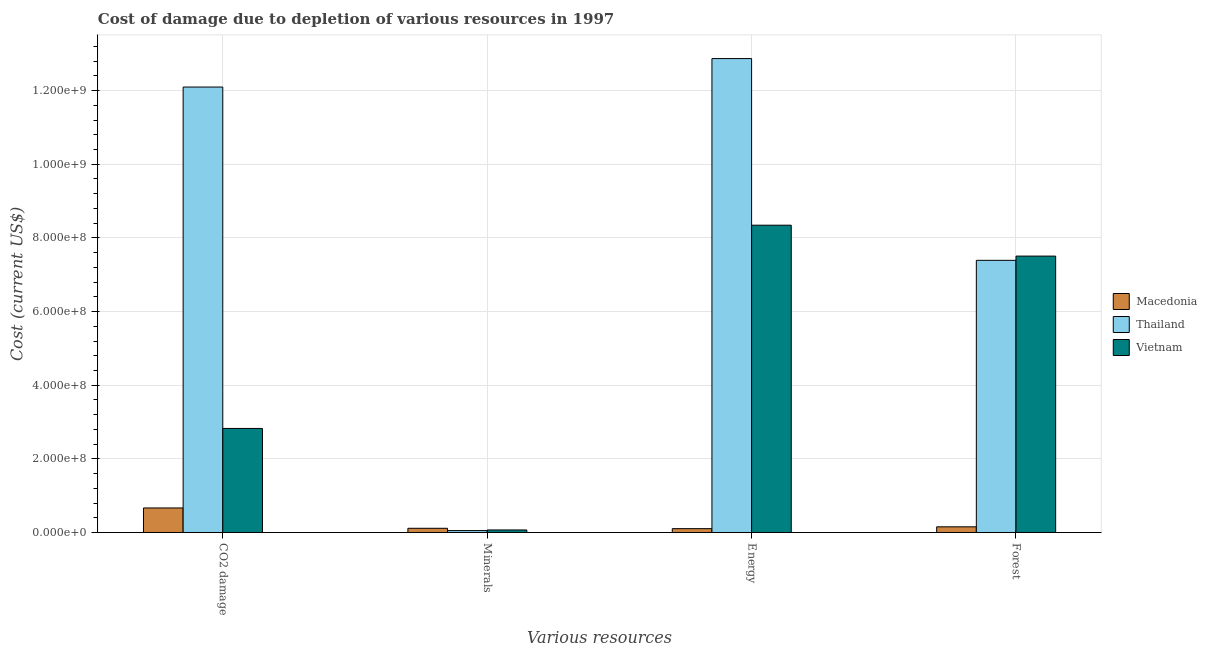How many different coloured bars are there?
Give a very brief answer. 3. How many groups of bars are there?
Offer a terse response. 4. Are the number of bars per tick equal to the number of legend labels?
Make the answer very short. Yes. Are the number of bars on each tick of the X-axis equal?
Make the answer very short. Yes. How many bars are there on the 2nd tick from the left?
Offer a very short reply. 3. How many bars are there on the 2nd tick from the right?
Ensure brevity in your answer.  3. What is the label of the 2nd group of bars from the left?
Make the answer very short. Minerals. What is the cost of damage due to depletion of energy in Macedonia?
Your answer should be very brief. 1.04e+07. Across all countries, what is the maximum cost of damage due to depletion of minerals?
Your answer should be compact. 1.14e+07. Across all countries, what is the minimum cost of damage due to depletion of forests?
Keep it short and to the point. 1.54e+07. In which country was the cost of damage due to depletion of forests maximum?
Provide a short and direct response. Vietnam. In which country was the cost of damage due to depletion of minerals minimum?
Ensure brevity in your answer.  Thailand. What is the total cost of damage due to depletion of minerals in the graph?
Keep it short and to the point. 2.34e+07. What is the difference between the cost of damage due to depletion of coal in Vietnam and that in Macedonia?
Provide a short and direct response. 2.16e+08. What is the difference between the cost of damage due to depletion of coal in Thailand and the cost of damage due to depletion of energy in Vietnam?
Give a very brief answer. 3.75e+08. What is the average cost of damage due to depletion of minerals per country?
Offer a terse response. 7.80e+06. What is the difference between the cost of damage due to depletion of minerals and cost of damage due to depletion of coal in Vietnam?
Give a very brief answer. -2.76e+08. In how many countries, is the cost of damage due to depletion of forests greater than 520000000 US$?
Your answer should be very brief. 2. What is the ratio of the cost of damage due to depletion of coal in Macedonia to that in Thailand?
Your answer should be compact. 0.06. Is the cost of damage due to depletion of energy in Vietnam less than that in Thailand?
Provide a succinct answer. Yes. What is the difference between the highest and the second highest cost of damage due to depletion of coal?
Provide a succinct answer. 9.27e+08. What is the difference between the highest and the lowest cost of damage due to depletion of minerals?
Offer a very short reply. 6.23e+06. Is the sum of the cost of damage due to depletion of energy in Thailand and Macedonia greater than the maximum cost of damage due to depletion of coal across all countries?
Offer a terse response. Yes. Is it the case that in every country, the sum of the cost of damage due to depletion of forests and cost of damage due to depletion of energy is greater than the sum of cost of damage due to depletion of coal and cost of damage due to depletion of minerals?
Keep it short and to the point. Yes. What does the 1st bar from the left in Minerals represents?
Provide a short and direct response. Macedonia. What does the 2nd bar from the right in Energy represents?
Your response must be concise. Thailand. Are the values on the major ticks of Y-axis written in scientific E-notation?
Offer a terse response. Yes. Where does the legend appear in the graph?
Give a very brief answer. Center right. What is the title of the graph?
Your response must be concise. Cost of damage due to depletion of various resources in 1997 . Does "Guam" appear as one of the legend labels in the graph?
Ensure brevity in your answer.  No. What is the label or title of the X-axis?
Offer a terse response. Various resources. What is the label or title of the Y-axis?
Make the answer very short. Cost (current US$). What is the Cost (current US$) in Macedonia in CO2 damage?
Your response must be concise. 6.66e+07. What is the Cost (current US$) in Thailand in CO2 damage?
Your answer should be very brief. 1.21e+09. What is the Cost (current US$) in Vietnam in CO2 damage?
Your response must be concise. 2.83e+08. What is the Cost (current US$) in Macedonia in Minerals?
Provide a succinct answer. 1.14e+07. What is the Cost (current US$) of Thailand in Minerals?
Offer a very short reply. 5.15e+06. What is the Cost (current US$) in Vietnam in Minerals?
Your answer should be compact. 6.86e+06. What is the Cost (current US$) of Macedonia in Energy?
Make the answer very short. 1.04e+07. What is the Cost (current US$) of Thailand in Energy?
Provide a succinct answer. 1.29e+09. What is the Cost (current US$) in Vietnam in Energy?
Provide a short and direct response. 8.35e+08. What is the Cost (current US$) in Macedonia in Forest?
Offer a terse response. 1.54e+07. What is the Cost (current US$) of Thailand in Forest?
Your answer should be compact. 7.39e+08. What is the Cost (current US$) of Vietnam in Forest?
Offer a very short reply. 7.51e+08. Across all Various resources, what is the maximum Cost (current US$) of Macedonia?
Ensure brevity in your answer.  6.66e+07. Across all Various resources, what is the maximum Cost (current US$) in Thailand?
Your response must be concise. 1.29e+09. Across all Various resources, what is the maximum Cost (current US$) in Vietnam?
Make the answer very short. 8.35e+08. Across all Various resources, what is the minimum Cost (current US$) in Macedonia?
Keep it short and to the point. 1.04e+07. Across all Various resources, what is the minimum Cost (current US$) in Thailand?
Keep it short and to the point. 5.15e+06. Across all Various resources, what is the minimum Cost (current US$) of Vietnam?
Ensure brevity in your answer.  6.86e+06. What is the total Cost (current US$) in Macedonia in the graph?
Your response must be concise. 1.04e+08. What is the total Cost (current US$) in Thailand in the graph?
Offer a very short reply. 3.24e+09. What is the total Cost (current US$) in Vietnam in the graph?
Your response must be concise. 1.87e+09. What is the difference between the Cost (current US$) of Macedonia in CO2 damage and that in Minerals?
Make the answer very short. 5.52e+07. What is the difference between the Cost (current US$) in Thailand in CO2 damage and that in Minerals?
Offer a very short reply. 1.20e+09. What is the difference between the Cost (current US$) of Vietnam in CO2 damage and that in Minerals?
Provide a short and direct response. 2.76e+08. What is the difference between the Cost (current US$) of Macedonia in CO2 damage and that in Energy?
Give a very brief answer. 5.62e+07. What is the difference between the Cost (current US$) in Thailand in CO2 damage and that in Energy?
Ensure brevity in your answer.  -7.73e+07. What is the difference between the Cost (current US$) in Vietnam in CO2 damage and that in Energy?
Keep it short and to the point. -5.52e+08. What is the difference between the Cost (current US$) in Macedonia in CO2 damage and that in Forest?
Keep it short and to the point. 5.12e+07. What is the difference between the Cost (current US$) of Thailand in CO2 damage and that in Forest?
Your response must be concise. 4.71e+08. What is the difference between the Cost (current US$) of Vietnam in CO2 damage and that in Forest?
Offer a terse response. -4.68e+08. What is the difference between the Cost (current US$) of Macedonia in Minerals and that in Energy?
Ensure brevity in your answer.  9.60e+05. What is the difference between the Cost (current US$) of Thailand in Minerals and that in Energy?
Ensure brevity in your answer.  -1.28e+09. What is the difference between the Cost (current US$) in Vietnam in Minerals and that in Energy?
Ensure brevity in your answer.  -8.28e+08. What is the difference between the Cost (current US$) in Macedonia in Minerals and that in Forest?
Your response must be concise. -4.00e+06. What is the difference between the Cost (current US$) of Thailand in Minerals and that in Forest?
Give a very brief answer. -7.34e+08. What is the difference between the Cost (current US$) in Vietnam in Minerals and that in Forest?
Your response must be concise. -7.44e+08. What is the difference between the Cost (current US$) in Macedonia in Energy and that in Forest?
Give a very brief answer. -4.96e+06. What is the difference between the Cost (current US$) of Thailand in Energy and that in Forest?
Ensure brevity in your answer.  5.48e+08. What is the difference between the Cost (current US$) of Vietnam in Energy and that in Forest?
Keep it short and to the point. 8.39e+07. What is the difference between the Cost (current US$) in Macedonia in CO2 damage and the Cost (current US$) in Thailand in Minerals?
Provide a succinct answer. 6.15e+07. What is the difference between the Cost (current US$) of Macedonia in CO2 damage and the Cost (current US$) of Vietnam in Minerals?
Provide a succinct answer. 5.98e+07. What is the difference between the Cost (current US$) of Thailand in CO2 damage and the Cost (current US$) of Vietnam in Minerals?
Your answer should be compact. 1.20e+09. What is the difference between the Cost (current US$) of Macedonia in CO2 damage and the Cost (current US$) of Thailand in Energy?
Your response must be concise. -1.22e+09. What is the difference between the Cost (current US$) of Macedonia in CO2 damage and the Cost (current US$) of Vietnam in Energy?
Your answer should be very brief. -7.68e+08. What is the difference between the Cost (current US$) in Thailand in CO2 damage and the Cost (current US$) in Vietnam in Energy?
Ensure brevity in your answer.  3.75e+08. What is the difference between the Cost (current US$) of Macedonia in CO2 damage and the Cost (current US$) of Thailand in Forest?
Make the answer very short. -6.72e+08. What is the difference between the Cost (current US$) in Macedonia in CO2 damage and the Cost (current US$) in Vietnam in Forest?
Offer a very short reply. -6.84e+08. What is the difference between the Cost (current US$) of Thailand in CO2 damage and the Cost (current US$) of Vietnam in Forest?
Keep it short and to the point. 4.59e+08. What is the difference between the Cost (current US$) in Macedonia in Minerals and the Cost (current US$) in Thailand in Energy?
Provide a succinct answer. -1.28e+09. What is the difference between the Cost (current US$) in Macedonia in Minerals and the Cost (current US$) in Vietnam in Energy?
Give a very brief answer. -8.23e+08. What is the difference between the Cost (current US$) of Thailand in Minerals and the Cost (current US$) of Vietnam in Energy?
Provide a short and direct response. -8.29e+08. What is the difference between the Cost (current US$) in Macedonia in Minerals and the Cost (current US$) in Thailand in Forest?
Your answer should be very brief. -7.28e+08. What is the difference between the Cost (current US$) in Macedonia in Minerals and the Cost (current US$) in Vietnam in Forest?
Your answer should be compact. -7.39e+08. What is the difference between the Cost (current US$) in Thailand in Minerals and the Cost (current US$) in Vietnam in Forest?
Provide a short and direct response. -7.45e+08. What is the difference between the Cost (current US$) in Macedonia in Energy and the Cost (current US$) in Thailand in Forest?
Give a very brief answer. -7.29e+08. What is the difference between the Cost (current US$) in Macedonia in Energy and the Cost (current US$) in Vietnam in Forest?
Provide a short and direct response. -7.40e+08. What is the difference between the Cost (current US$) of Thailand in Energy and the Cost (current US$) of Vietnam in Forest?
Offer a very short reply. 5.36e+08. What is the average Cost (current US$) of Macedonia per Various resources?
Keep it short and to the point. 2.60e+07. What is the average Cost (current US$) of Thailand per Various resources?
Offer a very short reply. 8.10e+08. What is the average Cost (current US$) in Vietnam per Various resources?
Your response must be concise. 4.69e+08. What is the difference between the Cost (current US$) in Macedonia and Cost (current US$) in Thailand in CO2 damage?
Provide a succinct answer. -1.14e+09. What is the difference between the Cost (current US$) of Macedonia and Cost (current US$) of Vietnam in CO2 damage?
Your answer should be compact. -2.16e+08. What is the difference between the Cost (current US$) in Thailand and Cost (current US$) in Vietnam in CO2 damage?
Your answer should be compact. 9.27e+08. What is the difference between the Cost (current US$) of Macedonia and Cost (current US$) of Thailand in Minerals?
Your answer should be compact. 6.23e+06. What is the difference between the Cost (current US$) of Macedonia and Cost (current US$) of Vietnam in Minerals?
Your response must be concise. 4.53e+06. What is the difference between the Cost (current US$) in Thailand and Cost (current US$) in Vietnam in Minerals?
Offer a very short reply. -1.71e+06. What is the difference between the Cost (current US$) of Macedonia and Cost (current US$) of Thailand in Energy?
Ensure brevity in your answer.  -1.28e+09. What is the difference between the Cost (current US$) of Macedonia and Cost (current US$) of Vietnam in Energy?
Offer a very short reply. -8.24e+08. What is the difference between the Cost (current US$) in Thailand and Cost (current US$) in Vietnam in Energy?
Make the answer very short. 4.53e+08. What is the difference between the Cost (current US$) in Macedonia and Cost (current US$) in Thailand in Forest?
Provide a succinct answer. -7.24e+08. What is the difference between the Cost (current US$) of Macedonia and Cost (current US$) of Vietnam in Forest?
Provide a short and direct response. -7.35e+08. What is the difference between the Cost (current US$) of Thailand and Cost (current US$) of Vietnam in Forest?
Offer a terse response. -1.15e+07. What is the ratio of the Cost (current US$) in Macedonia in CO2 damage to that in Minerals?
Your answer should be very brief. 5.85. What is the ratio of the Cost (current US$) of Thailand in CO2 damage to that in Minerals?
Offer a terse response. 234.72. What is the ratio of the Cost (current US$) of Vietnam in CO2 damage to that in Minerals?
Your response must be concise. 41.19. What is the ratio of the Cost (current US$) of Macedonia in CO2 damage to that in Energy?
Ensure brevity in your answer.  6.39. What is the ratio of the Cost (current US$) in Thailand in CO2 damage to that in Energy?
Provide a short and direct response. 0.94. What is the ratio of the Cost (current US$) of Vietnam in CO2 damage to that in Energy?
Your response must be concise. 0.34. What is the ratio of the Cost (current US$) in Macedonia in CO2 damage to that in Forest?
Keep it short and to the point. 4.33. What is the ratio of the Cost (current US$) in Thailand in CO2 damage to that in Forest?
Offer a terse response. 1.64. What is the ratio of the Cost (current US$) in Vietnam in CO2 damage to that in Forest?
Provide a succinct answer. 0.38. What is the ratio of the Cost (current US$) of Macedonia in Minerals to that in Energy?
Make the answer very short. 1.09. What is the ratio of the Cost (current US$) of Thailand in Minerals to that in Energy?
Give a very brief answer. 0. What is the ratio of the Cost (current US$) in Vietnam in Minerals to that in Energy?
Offer a terse response. 0.01. What is the ratio of the Cost (current US$) in Macedonia in Minerals to that in Forest?
Make the answer very short. 0.74. What is the ratio of the Cost (current US$) of Thailand in Minerals to that in Forest?
Your answer should be very brief. 0.01. What is the ratio of the Cost (current US$) of Vietnam in Minerals to that in Forest?
Provide a short and direct response. 0.01. What is the ratio of the Cost (current US$) in Macedonia in Energy to that in Forest?
Keep it short and to the point. 0.68. What is the ratio of the Cost (current US$) of Thailand in Energy to that in Forest?
Make the answer very short. 1.74. What is the ratio of the Cost (current US$) of Vietnam in Energy to that in Forest?
Keep it short and to the point. 1.11. What is the difference between the highest and the second highest Cost (current US$) of Macedonia?
Offer a terse response. 5.12e+07. What is the difference between the highest and the second highest Cost (current US$) of Thailand?
Make the answer very short. 7.73e+07. What is the difference between the highest and the second highest Cost (current US$) of Vietnam?
Offer a very short reply. 8.39e+07. What is the difference between the highest and the lowest Cost (current US$) in Macedonia?
Ensure brevity in your answer.  5.62e+07. What is the difference between the highest and the lowest Cost (current US$) of Thailand?
Your answer should be compact. 1.28e+09. What is the difference between the highest and the lowest Cost (current US$) in Vietnam?
Offer a terse response. 8.28e+08. 